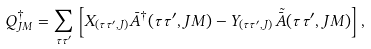Convert formula to latex. <formula><loc_0><loc_0><loc_500><loc_500>Q ^ { \dagger } _ { J M } = \sum _ { { \tau } { \tau ^ { \prime } } } \left [ X _ { ( { \tau } { \tau ^ { \prime } } , J ) } \bar { A } ^ { \dagger } ( { \tau } { \tau ^ { \prime } } , J M ) - Y _ { ( { \tau } { \tau ^ { \prime } } , J ) } \tilde { \bar { A } \, } ( { \tau } { \tau ^ { \prime } } , J M ) \right ] ,</formula> 